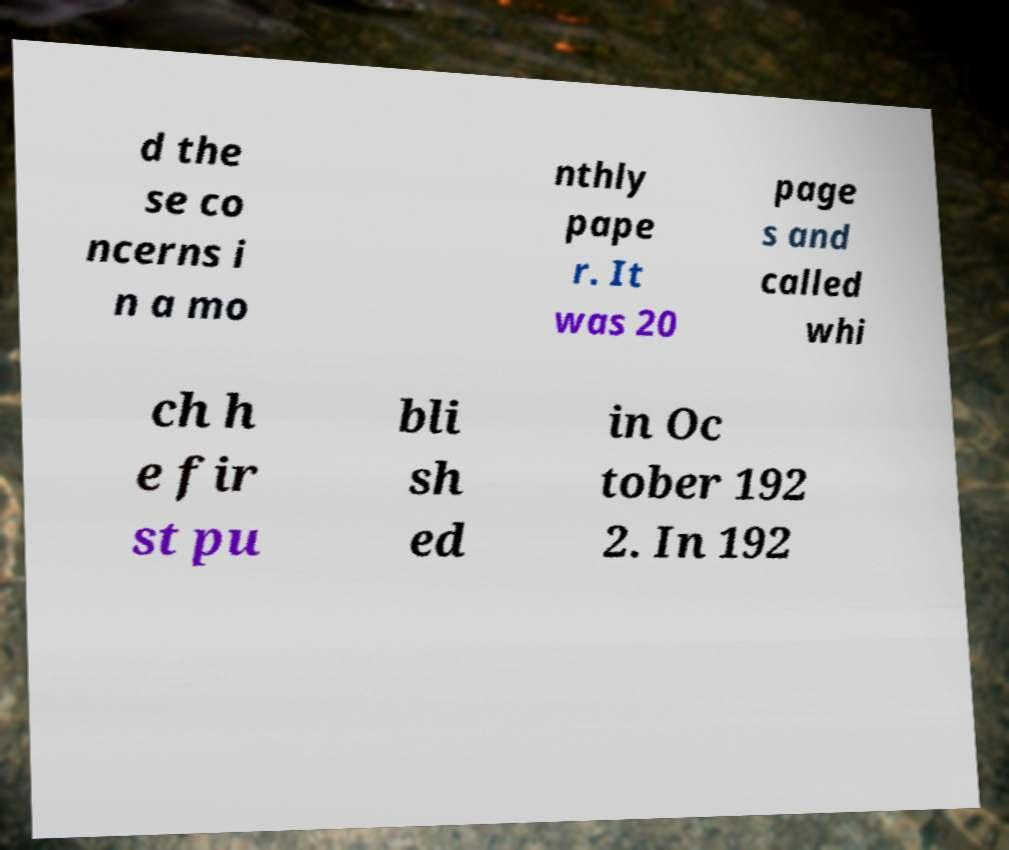Could you extract and type out the text from this image? d the se co ncerns i n a mo nthly pape r. It was 20 page s and called whi ch h e fir st pu bli sh ed in Oc tober 192 2. In 192 